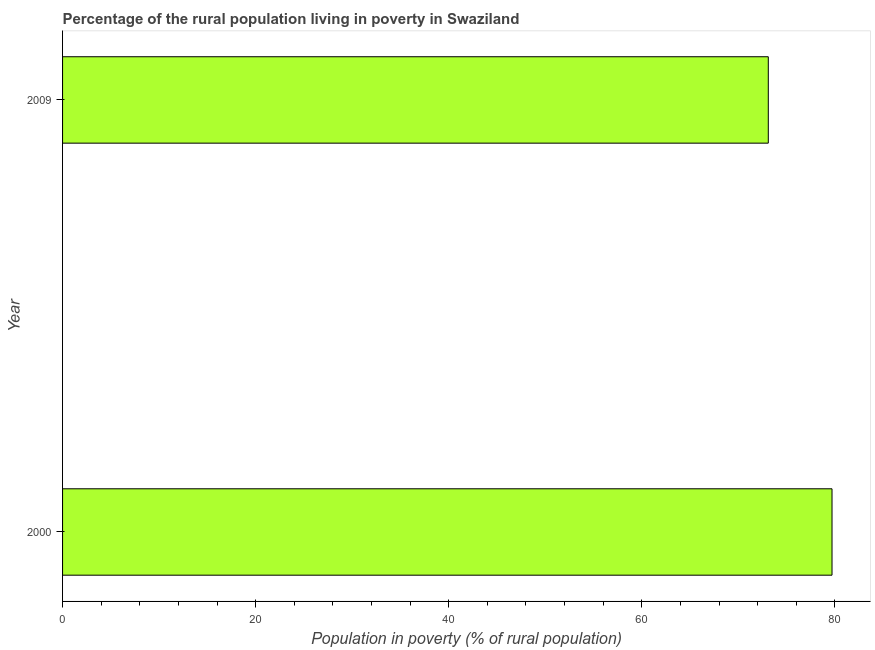What is the title of the graph?
Your answer should be very brief. Percentage of the rural population living in poverty in Swaziland. What is the label or title of the X-axis?
Offer a very short reply. Population in poverty (% of rural population). What is the percentage of rural population living below poverty line in 2009?
Your answer should be compact. 73.1. Across all years, what is the maximum percentage of rural population living below poverty line?
Offer a very short reply. 79.7. Across all years, what is the minimum percentage of rural population living below poverty line?
Your answer should be compact. 73.1. In which year was the percentage of rural population living below poverty line minimum?
Offer a terse response. 2009. What is the sum of the percentage of rural population living below poverty line?
Provide a succinct answer. 152.8. What is the difference between the percentage of rural population living below poverty line in 2000 and 2009?
Offer a very short reply. 6.6. What is the average percentage of rural population living below poverty line per year?
Your answer should be compact. 76.4. What is the median percentage of rural population living below poverty line?
Ensure brevity in your answer.  76.4. In how many years, is the percentage of rural population living below poverty line greater than 8 %?
Your answer should be compact. 2. What is the ratio of the percentage of rural population living below poverty line in 2000 to that in 2009?
Make the answer very short. 1.09. Is the percentage of rural population living below poverty line in 2000 less than that in 2009?
Ensure brevity in your answer.  No. How many years are there in the graph?
Make the answer very short. 2. What is the difference between two consecutive major ticks on the X-axis?
Ensure brevity in your answer.  20. Are the values on the major ticks of X-axis written in scientific E-notation?
Your answer should be compact. No. What is the Population in poverty (% of rural population) in 2000?
Provide a succinct answer. 79.7. What is the Population in poverty (% of rural population) in 2009?
Keep it short and to the point. 73.1. What is the ratio of the Population in poverty (% of rural population) in 2000 to that in 2009?
Ensure brevity in your answer.  1.09. 